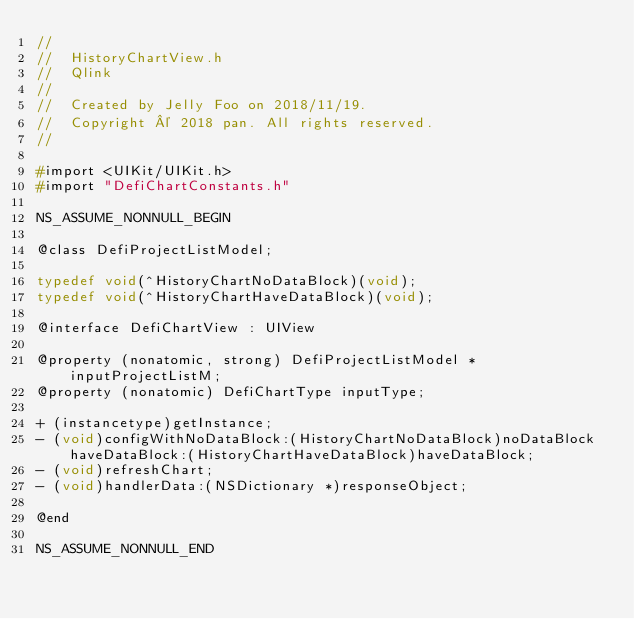Convert code to text. <code><loc_0><loc_0><loc_500><loc_500><_C_>//
//  HistoryChartView.h
//  Qlink
//
//  Created by Jelly Foo on 2018/11/19.
//  Copyright © 2018 pan. All rights reserved.
//

#import <UIKit/UIKit.h>
#import "DefiChartConstants.h"

NS_ASSUME_NONNULL_BEGIN

@class DefiProjectListModel;

typedef void(^HistoryChartNoDataBlock)(void);
typedef void(^HistoryChartHaveDataBlock)(void);

@interface DefiChartView : UIView

@property (nonatomic, strong) DefiProjectListModel *inputProjectListM;
@property (nonatomic) DefiChartType inputType;

+ (instancetype)getInstance;
- (void)configWithNoDataBlock:(HistoryChartNoDataBlock)noDataBlock haveDataBlock:(HistoryChartHaveDataBlock)haveDataBlock;
- (void)refreshChart;
- (void)handlerData:(NSDictionary *)responseObject;

@end

NS_ASSUME_NONNULL_END
</code> 